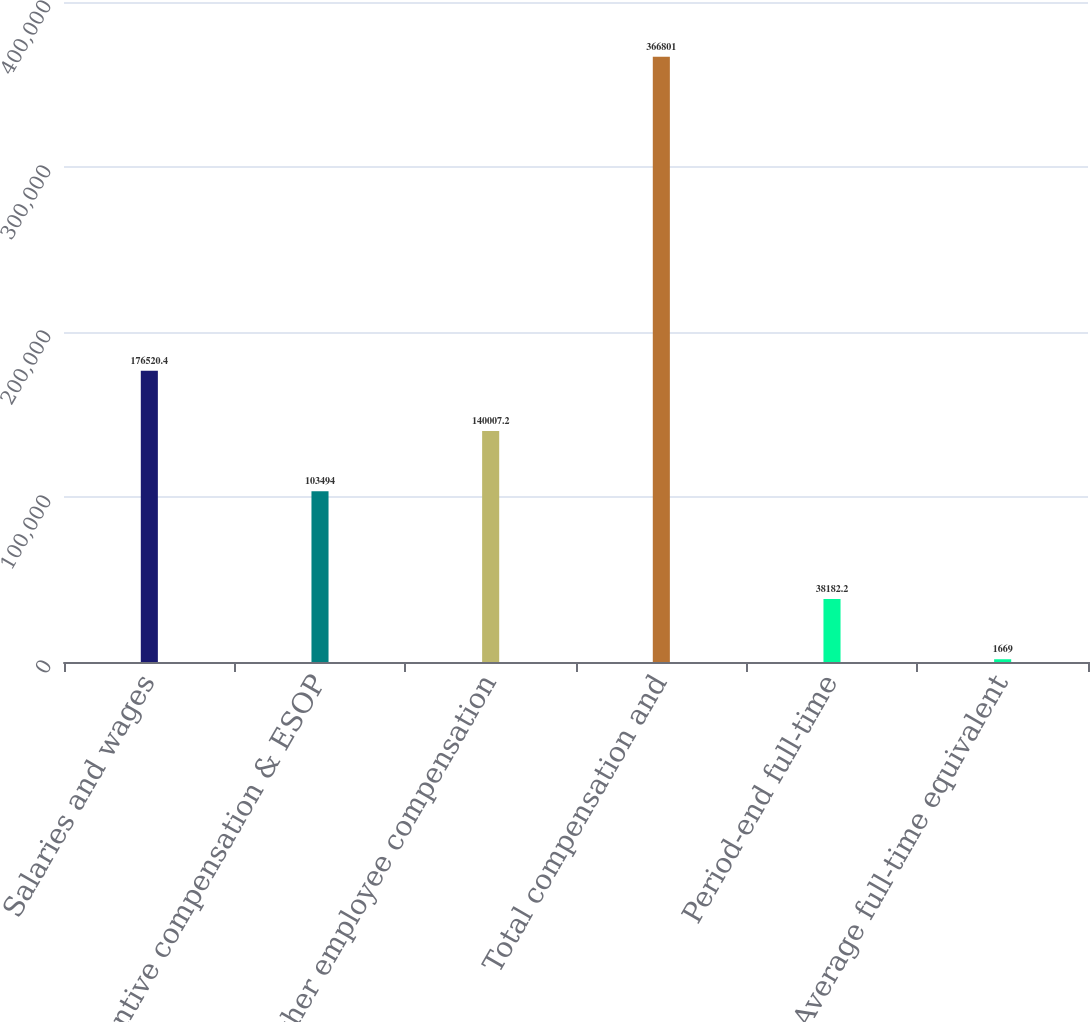<chart> <loc_0><loc_0><loc_500><loc_500><bar_chart><fcel>Salaries and wages<fcel>Incentive compensation & ESOP<fcel>Other employee compensation<fcel>Total compensation and<fcel>Period-end full-time<fcel>Average full-time equivalent<nl><fcel>176520<fcel>103494<fcel>140007<fcel>366801<fcel>38182.2<fcel>1669<nl></chart> 